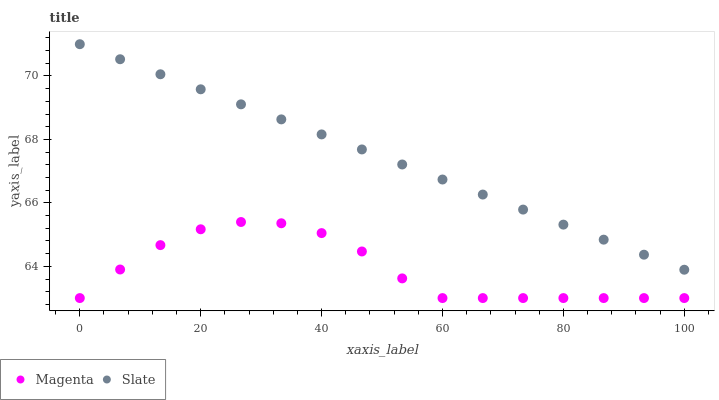Does Magenta have the minimum area under the curve?
Answer yes or no. Yes. Does Slate have the maximum area under the curve?
Answer yes or no. Yes. Does Slate have the minimum area under the curve?
Answer yes or no. No. Is Slate the smoothest?
Answer yes or no. Yes. Is Magenta the roughest?
Answer yes or no. Yes. Is Slate the roughest?
Answer yes or no. No. Does Magenta have the lowest value?
Answer yes or no. Yes. Does Slate have the lowest value?
Answer yes or no. No. Does Slate have the highest value?
Answer yes or no. Yes. Is Magenta less than Slate?
Answer yes or no. Yes. Is Slate greater than Magenta?
Answer yes or no. Yes. Does Magenta intersect Slate?
Answer yes or no. No. 